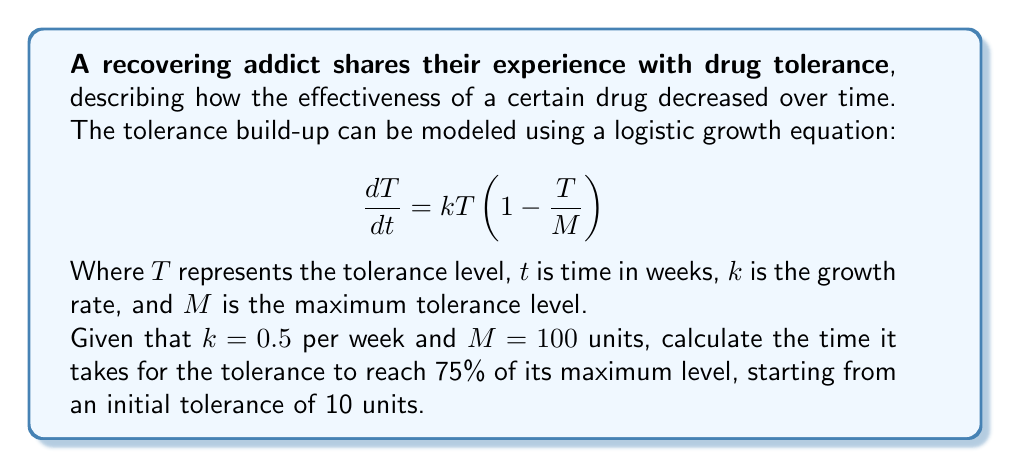Teach me how to tackle this problem. To solve this problem, we need to use the solution to the logistic growth equation:

1) The general solution to the logistic equation is:

   $$T(t) = \frac{M}{1 + (\frac{M}{T_0} - 1)e^{-kt}}$$

   Where $T_0$ is the initial tolerance level.

2) We're given:
   $k = 0.5$ per week
   $M = 100$ units
   $T_0 = 10$ units
   We want to find $t$ when $T = 0.75M = 75$ units

3) Substitute these values into the equation:

   $$75 = \frac{100}{1 + (\frac{100}{10} - 1)e^{-0.5t}}$$

4) Simplify:

   $$75 = \frac{100}{1 + 9e^{-0.5t}}$$

5) Multiply both sides by $(1 + 9e^{-0.5t})$:

   $$75(1 + 9e^{-0.5t}) = 100$$

6) Expand:

   $$75 + 675e^{-0.5t} = 100$$

7) Subtract 75 from both sides:

   $$675e^{-0.5t} = 25$$

8) Divide both sides by 675:

   $$e^{-0.5t} = \frac{1}{27}$$

9) Take the natural log of both sides:

   $$-0.5t = \ln(\frac{1}{27})$$

10) Solve for $t$:

    $$t = -\frac{2}{0.5}\ln(\frac{1}{27}) = 2\ln(27) \approx 6.59$$

Therefore, it takes approximately 6.59 weeks for the tolerance to reach 75% of its maximum level.
Answer: 6.59 weeks 